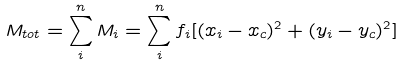Convert formula to latex. <formula><loc_0><loc_0><loc_500><loc_500>M _ { t o t } = \sum _ { i } ^ { n } M _ { i } = \sum _ { i } ^ { n } f _ { i } [ ( x _ { i } - x _ { c } ) ^ { 2 } + ( y _ { i } - y _ { c } ) ^ { 2 } ]</formula> 